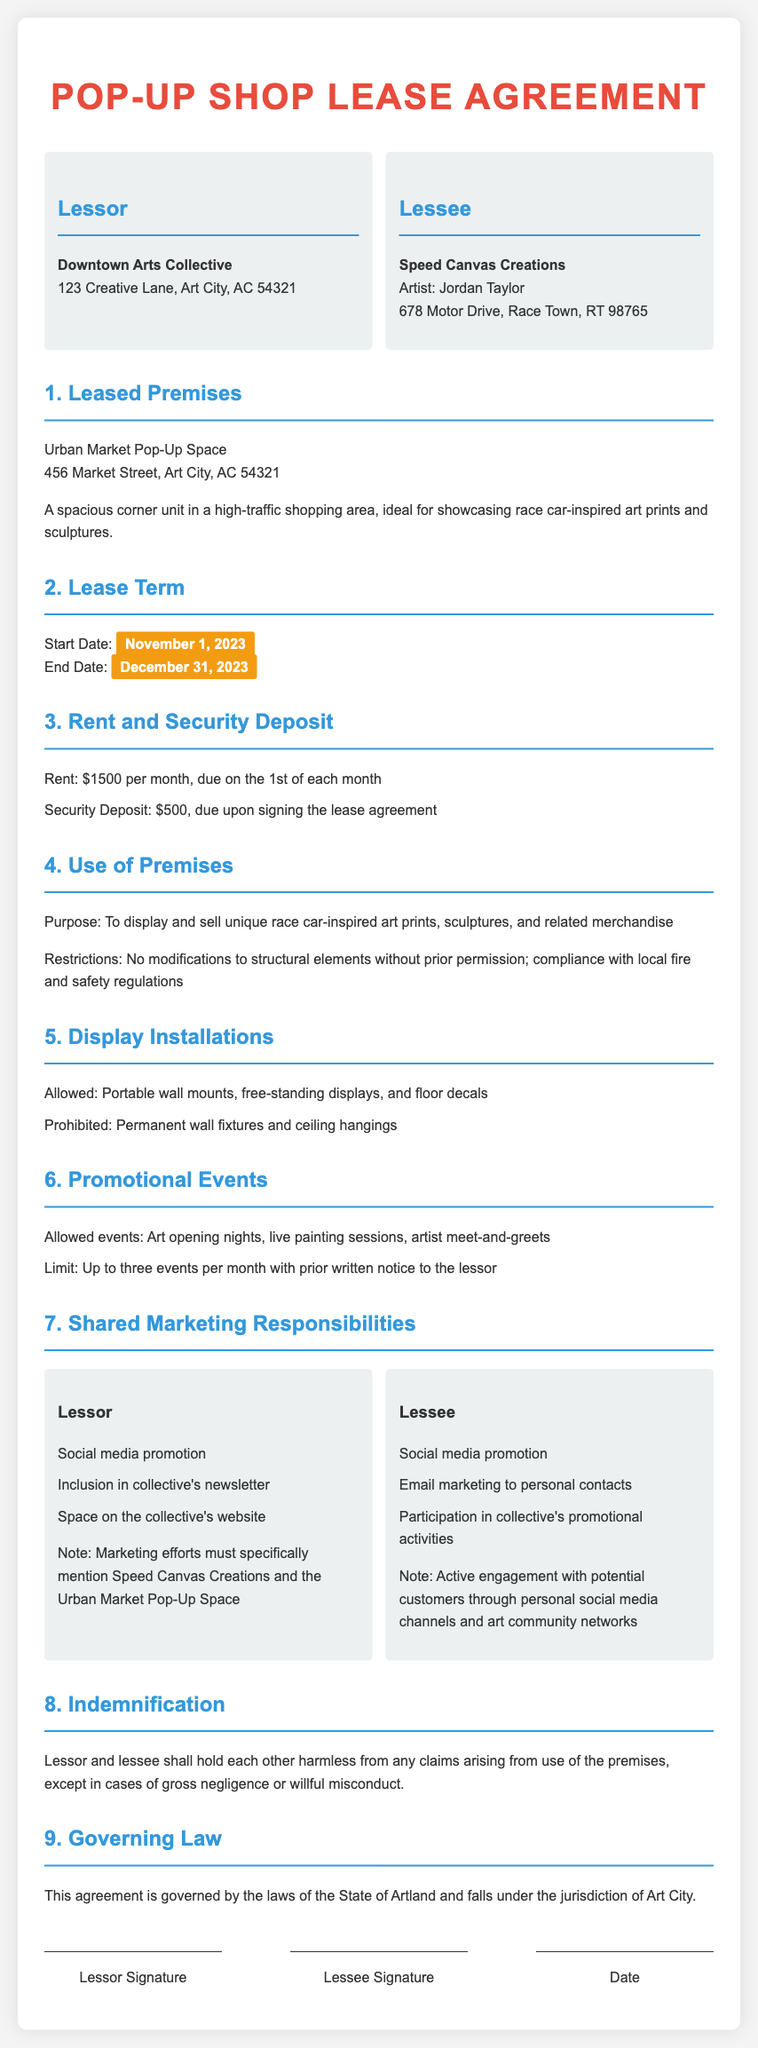What is the name of the lessor? The name of the lessor is specified in the document as Downtown Arts Collective.
Answer: Downtown Arts Collective What is the security deposit amount? The security deposit is listed in the document as due upon signing the lease agreement.
Answer: $500 What is the start date of the lease? The start date is clearly indicated in the lease agreement as November 1, 2023.
Answer: November 1, 2023 How many promotional events are allowed per month? The document states a limit on the number of events per month and specifies that it is up to three events.
Answer: Three What type of marketing responsibilities does the lessee have? The lessee's marketing responsibilities include promoting through social media and personal contacts as outlined in the lease agreement.
Answer: Social media promotion What is the purpose of the leased premises? The document specifies the purpose for which the premises are rented.
Answer: To display and sell unique race car-inspired art prints, sculptures, and related merchandise What is the rent amount? The rent amount is clearly detailed in the agreement as due on the 1st of each month.
Answer: $1500 What is prohibited in terms of display installations? The lease agreement outlines what types of installations are prohibited on the premises.
Answer: Permanent wall fixtures and ceiling hangings What law governs this lease agreement? The governing law applicable to this agreement is specified within the document.
Answer: The laws of the State of Artland 